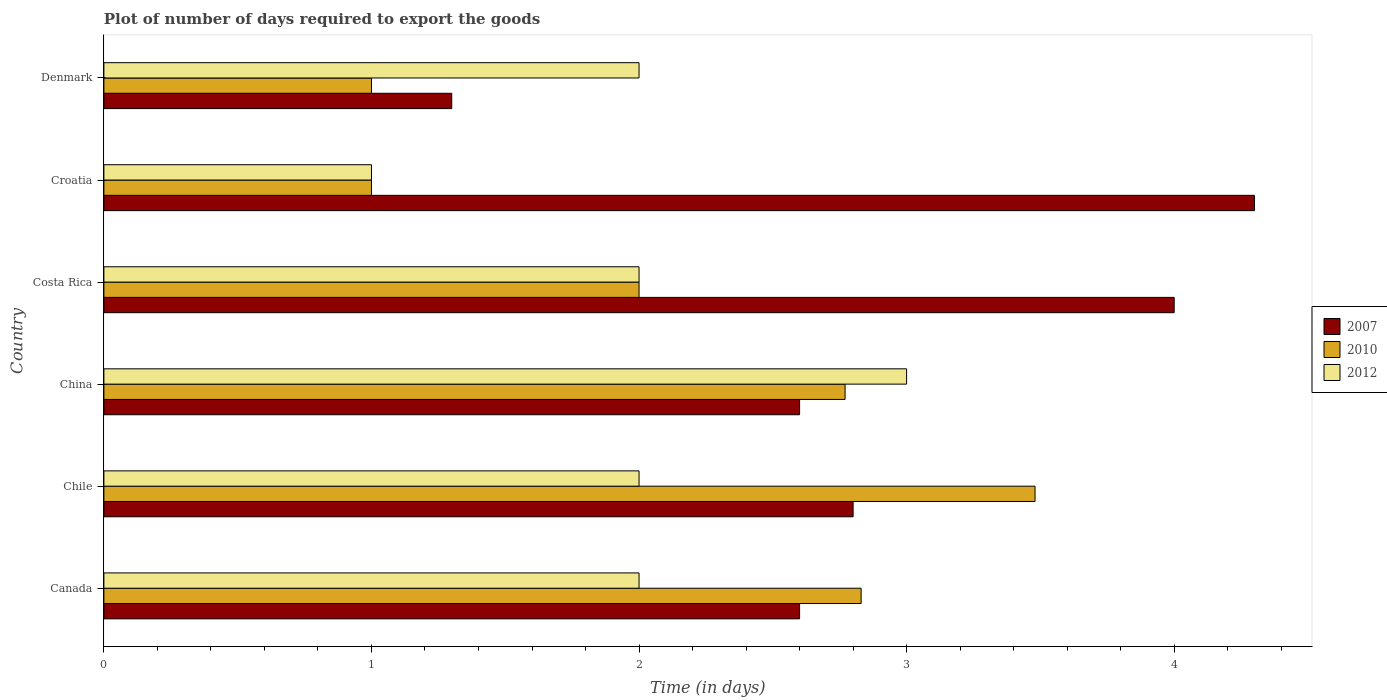How many bars are there on the 3rd tick from the top?
Your response must be concise. 3. What is the label of the 2nd group of bars from the top?
Offer a terse response. Croatia. What is the time required to export goods in 2010 in Chile?
Provide a short and direct response. 3.48. Across all countries, what is the maximum time required to export goods in 2010?
Your answer should be compact. 3.48. In which country was the time required to export goods in 2012 minimum?
Offer a terse response. Croatia. What is the total time required to export goods in 2007 in the graph?
Make the answer very short. 17.6. What is the difference between the time required to export goods in 2007 in Chile and the time required to export goods in 2012 in Costa Rica?
Keep it short and to the point. 0.8. What is the average time required to export goods in 2010 per country?
Your response must be concise. 2.18. What is the difference between the time required to export goods in 2010 and time required to export goods in 2007 in Chile?
Your answer should be very brief. 0.68. What is the ratio of the time required to export goods in 2010 in Chile to that in Croatia?
Give a very brief answer. 3.48. Is the time required to export goods in 2010 in China less than that in Croatia?
Your answer should be very brief. No. What is the difference between the highest and the lowest time required to export goods in 2012?
Provide a short and direct response. 2. In how many countries, is the time required to export goods in 2012 greater than the average time required to export goods in 2012 taken over all countries?
Provide a short and direct response. 1. What does the 3rd bar from the bottom in Chile represents?
Your response must be concise. 2012. How many countries are there in the graph?
Provide a short and direct response. 6. What is the difference between two consecutive major ticks on the X-axis?
Your answer should be compact. 1. Are the values on the major ticks of X-axis written in scientific E-notation?
Provide a short and direct response. No. Does the graph contain grids?
Make the answer very short. No. Where does the legend appear in the graph?
Keep it short and to the point. Center right. How many legend labels are there?
Ensure brevity in your answer.  3. How are the legend labels stacked?
Your answer should be compact. Vertical. What is the title of the graph?
Make the answer very short. Plot of number of days required to export the goods. Does "1995" appear as one of the legend labels in the graph?
Provide a succinct answer. No. What is the label or title of the X-axis?
Provide a short and direct response. Time (in days). What is the label or title of the Y-axis?
Your answer should be compact. Country. What is the Time (in days) in 2010 in Canada?
Ensure brevity in your answer.  2.83. What is the Time (in days) of 2007 in Chile?
Make the answer very short. 2.8. What is the Time (in days) in 2010 in Chile?
Your answer should be compact. 3.48. What is the Time (in days) in 2012 in Chile?
Provide a succinct answer. 2. What is the Time (in days) of 2010 in China?
Offer a very short reply. 2.77. What is the Time (in days) of 2007 in Costa Rica?
Your answer should be very brief. 4. What is the Time (in days) of 2010 in Costa Rica?
Your response must be concise. 2. What is the Time (in days) in 2007 in Croatia?
Offer a terse response. 4.3. What is the Time (in days) in 2010 in Croatia?
Ensure brevity in your answer.  1. What is the Time (in days) of 2012 in Croatia?
Your answer should be very brief. 1. What is the Time (in days) of 2007 in Denmark?
Provide a succinct answer. 1.3. What is the Time (in days) in 2012 in Denmark?
Provide a succinct answer. 2. Across all countries, what is the maximum Time (in days) of 2010?
Make the answer very short. 3.48. Across all countries, what is the maximum Time (in days) of 2012?
Provide a succinct answer. 3. Across all countries, what is the minimum Time (in days) of 2010?
Your answer should be very brief. 1. What is the total Time (in days) of 2010 in the graph?
Ensure brevity in your answer.  13.08. What is the difference between the Time (in days) of 2010 in Canada and that in Chile?
Make the answer very short. -0.65. What is the difference between the Time (in days) of 2007 in Canada and that in China?
Give a very brief answer. 0. What is the difference between the Time (in days) in 2012 in Canada and that in China?
Your answer should be compact. -1. What is the difference between the Time (in days) in 2007 in Canada and that in Costa Rica?
Offer a terse response. -1.4. What is the difference between the Time (in days) in 2010 in Canada and that in Costa Rica?
Give a very brief answer. 0.83. What is the difference between the Time (in days) of 2012 in Canada and that in Costa Rica?
Your answer should be very brief. 0. What is the difference between the Time (in days) of 2010 in Canada and that in Croatia?
Your answer should be very brief. 1.83. What is the difference between the Time (in days) in 2010 in Canada and that in Denmark?
Give a very brief answer. 1.83. What is the difference between the Time (in days) in 2010 in Chile and that in China?
Ensure brevity in your answer.  0.71. What is the difference between the Time (in days) of 2012 in Chile and that in China?
Keep it short and to the point. -1. What is the difference between the Time (in days) of 2007 in Chile and that in Costa Rica?
Make the answer very short. -1.2. What is the difference between the Time (in days) in 2010 in Chile and that in Costa Rica?
Your answer should be compact. 1.48. What is the difference between the Time (in days) of 2012 in Chile and that in Costa Rica?
Your answer should be compact. 0. What is the difference between the Time (in days) of 2010 in Chile and that in Croatia?
Your answer should be compact. 2.48. What is the difference between the Time (in days) of 2007 in Chile and that in Denmark?
Your response must be concise. 1.5. What is the difference between the Time (in days) of 2010 in Chile and that in Denmark?
Keep it short and to the point. 2.48. What is the difference between the Time (in days) of 2012 in Chile and that in Denmark?
Your response must be concise. 0. What is the difference between the Time (in days) of 2010 in China and that in Costa Rica?
Your response must be concise. 0.77. What is the difference between the Time (in days) in 2007 in China and that in Croatia?
Offer a very short reply. -1.7. What is the difference between the Time (in days) of 2010 in China and that in Croatia?
Offer a terse response. 1.77. What is the difference between the Time (in days) in 2012 in China and that in Croatia?
Give a very brief answer. 2. What is the difference between the Time (in days) in 2007 in China and that in Denmark?
Provide a succinct answer. 1.3. What is the difference between the Time (in days) of 2010 in China and that in Denmark?
Keep it short and to the point. 1.77. What is the difference between the Time (in days) of 2007 in Costa Rica and that in Croatia?
Offer a terse response. -0.3. What is the difference between the Time (in days) of 2012 in Costa Rica and that in Croatia?
Provide a short and direct response. 1. What is the difference between the Time (in days) of 2007 in Canada and the Time (in days) of 2010 in Chile?
Make the answer very short. -0.88. What is the difference between the Time (in days) in 2007 in Canada and the Time (in days) in 2012 in Chile?
Keep it short and to the point. 0.6. What is the difference between the Time (in days) of 2010 in Canada and the Time (in days) of 2012 in Chile?
Provide a short and direct response. 0.83. What is the difference between the Time (in days) of 2007 in Canada and the Time (in days) of 2010 in China?
Keep it short and to the point. -0.17. What is the difference between the Time (in days) in 2010 in Canada and the Time (in days) in 2012 in China?
Offer a very short reply. -0.17. What is the difference between the Time (in days) in 2010 in Canada and the Time (in days) in 2012 in Costa Rica?
Offer a very short reply. 0.83. What is the difference between the Time (in days) in 2007 in Canada and the Time (in days) in 2010 in Croatia?
Keep it short and to the point. 1.6. What is the difference between the Time (in days) in 2010 in Canada and the Time (in days) in 2012 in Croatia?
Offer a terse response. 1.83. What is the difference between the Time (in days) of 2007 in Canada and the Time (in days) of 2010 in Denmark?
Offer a very short reply. 1.6. What is the difference between the Time (in days) in 2010 in Canada and the Time (in days) in 2012 in Denmark?
Offer a terse response. 0.83. What is the difference between the Time (in days) of 2007 in Chile and the Time (in days) of 2010 in China?
Your answer should be compact. 0.03. What is the difference between the Time (in days) of 2010 in Chile and the Time (in days) of 2012 in China?
Ensure brevity in your answer.  0.48. What is the difference between the Time (in days) in 2010 in Chile and the Time (in days) in 2012 in Costa Rica?
Provide a succinct answer. 1.48. What is the difference between the Time (in days) of 2007 in Chile and the Time (in days) of 2012 in Croatia?
Offer a very short reply. 1.8. What is the difference between the Time (in days) in 2010 in Chile and the Time (in days) in 2012 in Croatia?
Offer a terse response. 2.48. What is the difference between the Time (in days) of 2007 in Chile and the Time (in days) of 2010 in Denmark?
Provide a short and direct response. 1.8. What is the difference between the Time (in days) in 2010 in Chile and the Time (in days) in 2012 in Denmark?
Provide a succinct answer. 1.48. What is the difference between the Time (in days) of 2010 in China and the Time (in days) of 2012 in Costa Rica?
Provide a succinct answer. 0.77. What is the difference between the Time (in days) in 2007 in China and the Time (in days) in 2012 in Croatia?
Provide a short and direct response. 1.6. What is the difference between the Time (in days) of 2010 in China and the Time (in days) of 2012 in Croatia?
Make the answer very short. 1.77. What is the difference between the Time (in days) in 2007 in China and the Time (in days) in 2010 in Denmark?
Ensure brevity in your answer.  1.6. What is the difference between the Time (in days) of 2007 in China and the Time (in days) of 2012 in Denmark?
Offer a very short reply. 0.6. What is the difference between the Time (in days) of 2010 in China and the Time (in days) of 2012 in Denmark?
Give a very brief answer. 0.77. What is the difference between the Time (in days) of 2007 in Costa Rica and the Time (in days) of 2010 in Denmark?
Provide a short and direct response. 3. What is the difference between the Time (in days) of 2010 in Costa Rica and the Time (in days) of 2012 in Denmark?
Provide a succinct answer. 0. What is the difference between the Time (in days) in 2007 in Croatia and the Time (in days) in 2010 in Denmark?
Ensure brevity in your answer.  3.3. What is the average Time (in days) in 2007 per country?
Your answer should be compact. 2.93. What is the average Time (in days) in 2010 per country?
Make the answer very short. 2.18. What is the average Time (in days) of 2012 per country?
Offer a terse response. 2. What is the difference between the Time (in days) of 2007 and Time (in days) of 2010 in Canada?
Offer a terse response. -0.23. What is the difference between the Time (in days) of 2007 and Time (in days) of 2012 in Canada?
Your answer should be compact. 0.6. What is the difference between the Time (in days) of 2010 and Time (in days) of 2012 in Canada?
Make the answer very short. 0.83. What is the difference between the Time (in days) of 2007 and Time (in days) of 2010 in Chile?
Give a very brief answer. -0.68. What is the difference between the Time (in days) in 2010 and Time (in days) in 2012 in Chile?
Make the answer very short. 1.48. What is the difference between the Time (in days) of 2007 and Time (in days) of 2010 in China?
Ensure brevity in your answer.  -0.17. What is the difference between the Time (in days) in 2010 and Time (in days) in 2012 in China?
Keep it short and to the point. -0.23. What is the difference between the Time (in days) in 2007 and Time (in days) in 2012 in Costa Rica?
Keep it short and to the point. 2. What is the difference between the Time (in days) of 2007 and Time (in days) of 2012 in Croatia?
Offer a very short reply. 3.3. What is the difference between the Time (in days) of 2010 and Time (in days) of 2012 in Croatia?
Your response must be concise. 0. What is the ratio of the Time (in days) of 2007 in Canada to that in Chile?
Your response must be concise. 0.93. What is the ratio of the Time (in days) of 2010 in Canada to that in Chile?
Provide a short and direct response. 0.81. What is the ratio of the Time (in days) of 2012 in Canada to that in Chile?
Offer a terse response. 1. What is the ratio of the Time (in days) in 2010 in Canada to that in China?
Offer a terse response. 1.02. What is the ratio of the Time (in days) of 2007 in Canada to that in Costa Rica?
Make the answer very short. 0.65. What is the ratio of the Time (in days) in 2010 in Canada to that in Costa Rica?
Offer a very short reply. 1.42. What is the ratio of the Time (in days) of 2007 in Canada to that in Croatia?
Offer a very short reply. 0.6. What is the ratio of the Time (in days) in 2010 in Canada to that in Croatia?
Ensure brevity in your answer.  2.83. What is the ratio of the Time (in days) of 2012 in Canada to that in Croatia?
Make the answer very short. 2. What is the ratio of the Time (in days) of 2007 in Canada to that in Denmark?
Provide a succinct answer. 2. What is the ratio of the Time (in days) of 2010 in Canada to that in Denmark?
Offer a very short reply. 2.83. What is the ratio of the Time (in days) of 2012 in Canada to that in Denmark?
Provide a short and direct response. 1. What is the ratio of the Time (in days) of 2010 in Chile to that in China?
Your answer should be compact. 1.26. What is the ratio of the Time (in days) in 2010 in Chile to that in Costa Rica?
Offer a terse response. 1.74. What is the ratio of the Time (in days) in 2007 in Chile to that in Croatia?
Offer a terse response. 0.65. What is the ratio of the Time (in days) in 2010 in Chile to that in Croatia?
Offer a terse response. 3.48. What is the ratio of the Time (in days) of 2007 in Chile to that in Denmark?
Offer a very short reply. 2.15. What is the ratio of the Time (in days) in 2010 in Chile to that in Denmark?
Keep it short and to the point. 3.48. What is the ratio of the Time (in days) in 2012 in Chile to that in Denmark?
Offer a terse response. 1. What is the ratio of the Time (in days) in 2007 in China to that in Costa Rica?
Give a very brief answer. 0.65. What is the ratio of the Time (in days) of 2010 in China to that in Costa Rica?
Provide a succinct answer. 1.39. What is the ratio of the Time (in days) of 2012 in China to that in Costa Rica?
Ensure brevity in your answer.  1.5. What is the ratio of the Time (in days) of 2007 in China to that in Croatia?
Your response must be concise. 0.6. What is the ratio of the Time (in days) of 2010 in China to that in Croatia?
Ensure brevity in your answer.  2.77. What is the ratio of the Time (in days) of 2012 in China to that in Croatia?
Provide a short and direct response. 3. What is the ratio of the Time (in days) in 2010 in China to that in Denmark?
Your answer should be compact. 2.77. What is the ratio of the Time (in days) in 2007 in Costa Rica to that in Croatia?
Offer a terse response. 0.93. What is the ratio of the Time (in days) in 2012 in Costa Rica to that in Croatia?
Provide a short and direct response. 2. What is the ratio of the Time (in days) of 2007 in Costa Rica to that in Denmark?
Provide a short and direct response. 3.08. What is the ratio of the Time (in days) in 2007 in Croatia to that in Denmark?
Ensure brevity in your answer.  3.31. What is the ratio of the Time (in days) of 2010 in Croatia to that in Denmark?
Your answer should be compact. 1. What is the ratio of the Time (in days) in 2012 in Croatia to that in Denmark?
Your answer should be compact. 0.5. What is the difference between the highest and the second highest Time (in days) in 2010?
Offer a very short reply. 0.65. What is the difference between the highest and the lowest Time (in days) of 2010?
Your answer should be very brief. 2.48. 